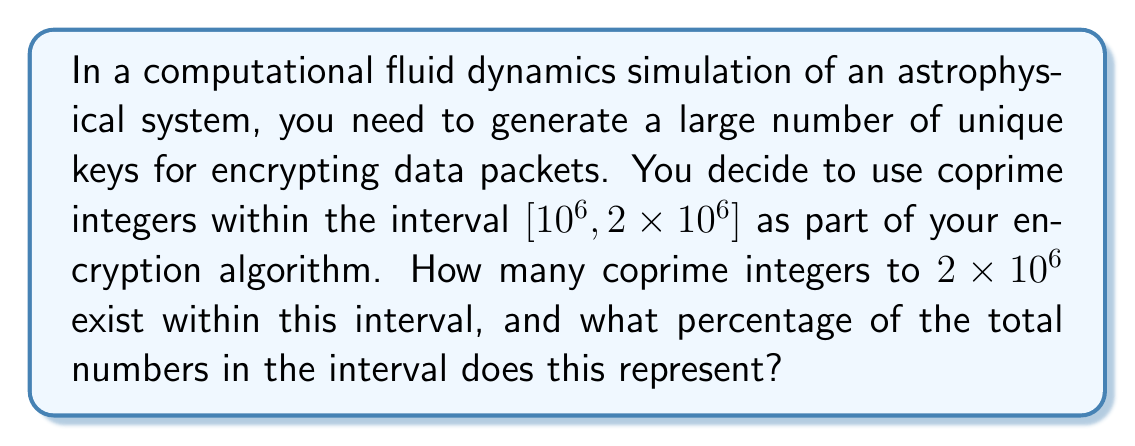Teach me how to tackle this problem. Let's approach this step-by-step:

1) First, we need to find the number of integers in the interval $[10^6, 2 \times 10^6]$:
   $2 \times 10^6 - 10^6 + 1 = 10^6 + 1 = 1,000,001$

2) Now, we need to find how many of these are coprime to $2 \times 10^6$. 
   To be coprime to $2 \times 10^6$, a number must not share any prime factors with it.

3) The prime factorization of $2 \times 10^6$ is $2^6 \times 5^6$.

4) To count the coprime numbers, we can use the principle of inclusion-exclusion with Euler's totient function:

   $$\phi(2 \times 10^6, 10^6, 2 \times 10^6) = 10^6 \times (1 - \frac{1}{2})(1 - \frac{1}{5})$$

5) Calculating this:
   $$10^6 \times \frac{1}{2} \times \frac{4}{5} = 400,000$$

6) To get the percentage, we divide by the total number of integers and multiply by 100:

   $$\frac{400,000}{1,000,001} \times 100 \approx 39.9999\%$$

This method of using coprime integers is relevant to encryption algorithms because coprime numbers have special properties in modular arithmetic, which is fundamental to many cryptographic systems. The large number of coprimes available provides a good pool of potential keys, enhancing the security of the encryption.
Answer: 400,000 coprime integers, representing approximately 40% of the interval. 